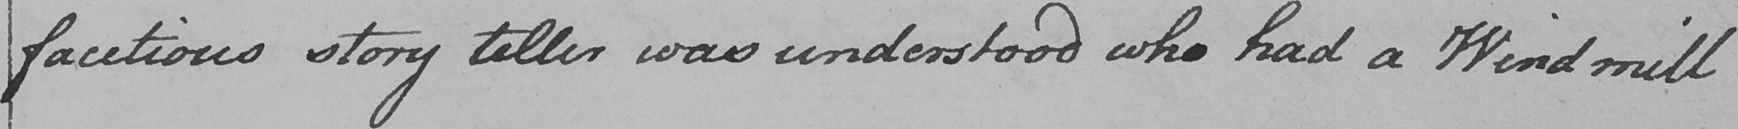What text is written in this handwritten line? facetious story teller was understood who had a Wind mill 